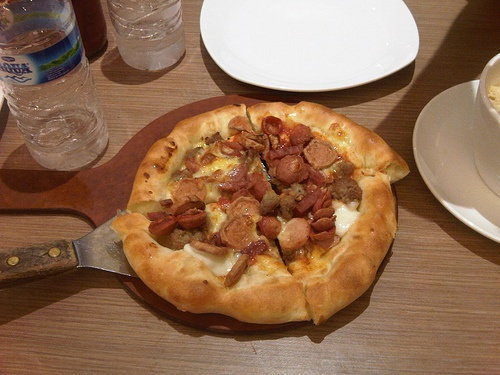Describe the objects in this image and their specific colors. I can see dining table in gray, maroon, brown, white, and tan tones, pizza in maroon, brown, tan, and salmon tones, bottle in maroon, gray, and black tones, bottle in maroon, gray, and darkgray tones, and bowl in maroon, gray, and tan tones in this image. 